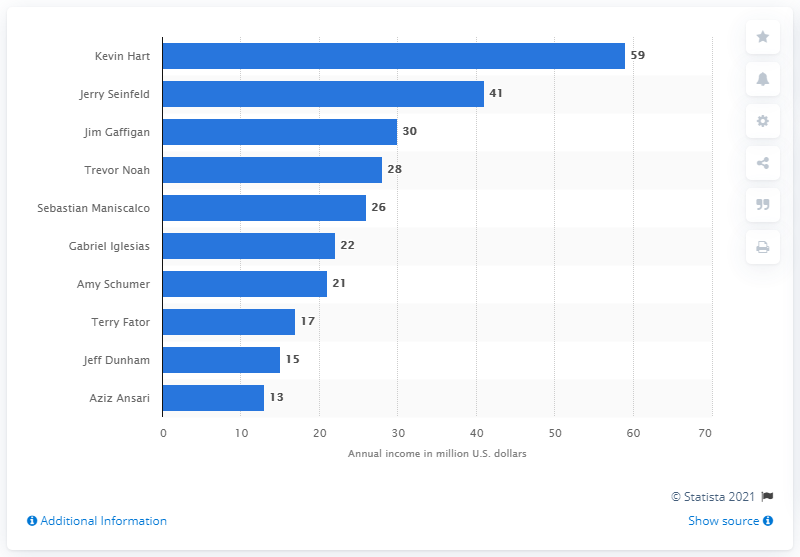Specify some key components in this picture. It is reported that Kevin Hart earned approximately $59 million between June 2018 and June 2019. 